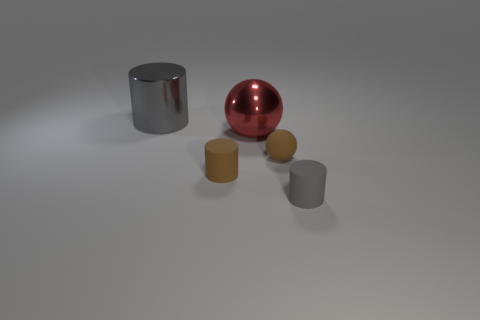Subtract all red balls. Subtract all brown cylinders. How many balls are left? 1 Add 5 rubber balls. How many objects exist? 10 Subtract all cylinders. How many objects are left? 2 Add 2 tiny things. How many tiny things are left? 5 Add 2 gray cylinders. How many gray cylinders exist? 4 Subtract 0 purple balls. How many objects are left? 5 Subtract all small rubber spheres. Subtract all metallic cylinders. How many objects are left? 3 